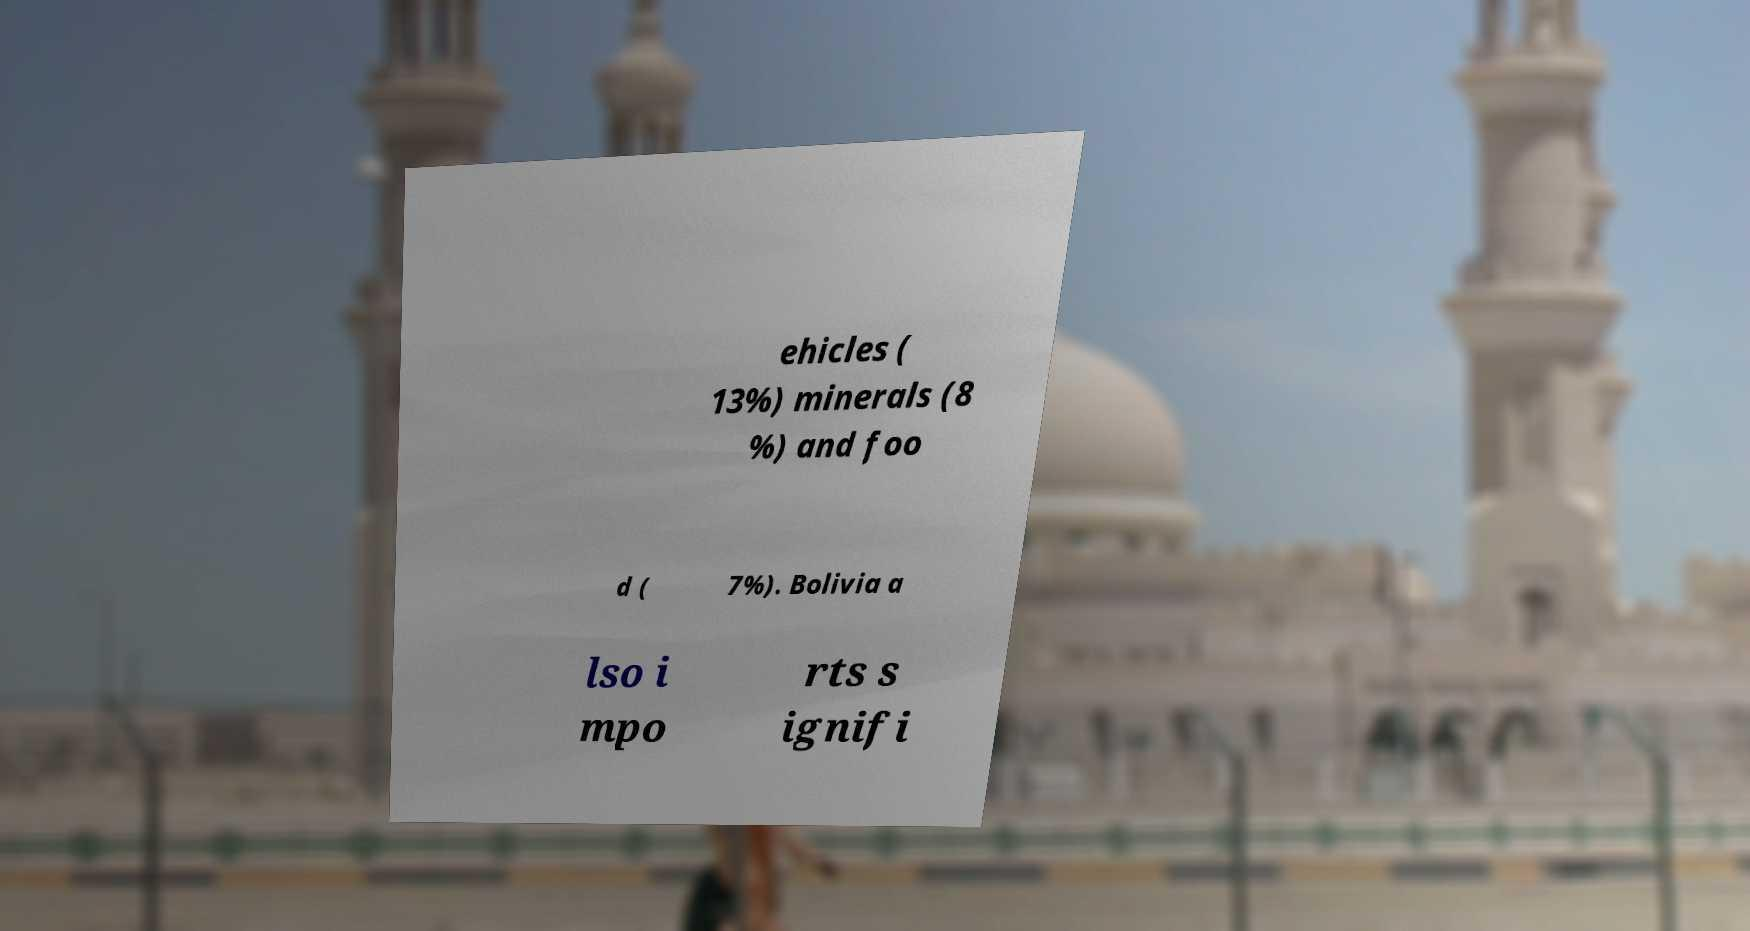Could you assist in decoding the text presented in this image and type it out clearly? ehicles ( 13%) minerals (8 %) and foo d ( 7%). Bolivia a lso i mpo rts s ignifi 